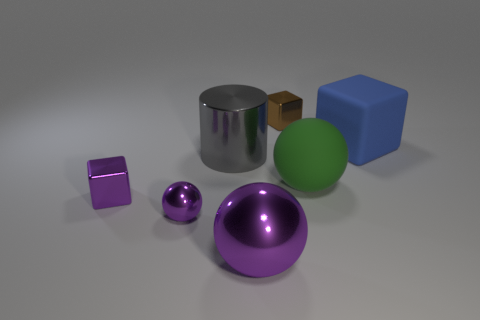Add 2 cylinders. How many objects exist? 9 Subtract all purple metal spheres. How many spheres are left? 1 Subtract all cubes. How many objects are left? 4 Subtract all gray blocks. Subtract all blue spheres. How many blocks are left? 3 Subtract all blue matte things. Subtract all gray shiny cylinders. How many objects are left? 5 Add 3 brown things. How many brown things are left? 4 Add 1 gray metallic cylinders. How many gray metallic cylinders exist? 2 Subtract 0 green cylinders. How many objects are left? 7 